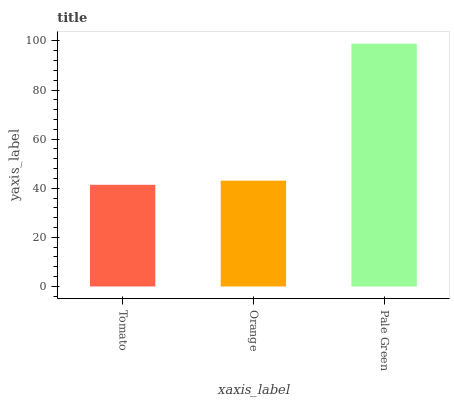Is Tomato the minimum?
Answer yes or no. Yes. Is Pale Green the maximum?
Answer yes or no. Yes. Is Orange the minimum?
Answer yes or no. No. Is Orange the maximum?
Answer yes or no. No. Is Orange greater than Tomato?
Answer yes or no. Yes. Is Tomato less than Orange?
Answer yes or no. Yes. Is Tomato greater than Orange?
Answer yes or no. No. Is Orange less than Tomato?
Answer yes or no. No. Is Orange the high median?
Answer yes or no. Yes. Is Orange the low median?
Answer yes or no. Yes. Is Tomato the high median?
Answer yes or no. No. Is Tomato the low median?
Answer yes or no. No. 